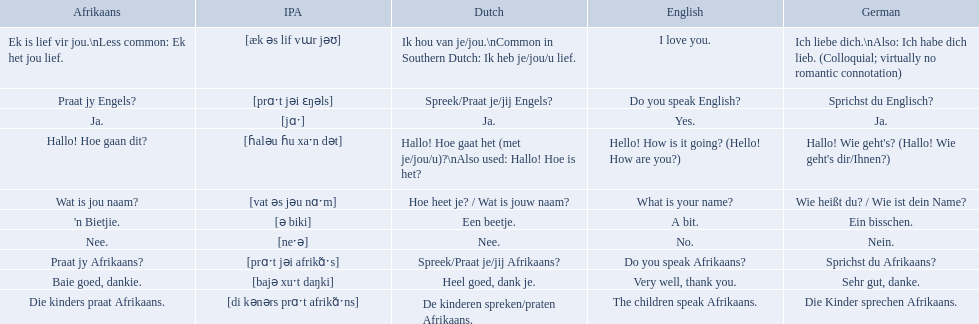What are the listed afrikaans phrases? Hallo! Hoe gaan dit?, Baie goed, dankie., Praat jy Afrikaans?, Praat jy Engels?, Ja., Nee., 'n Bietjie., Wat is jou naam?, Die kinders praat Afrikaans., Ek is lief vir jou.\nLess common: Ek het jou lief. Which is die kinders praat afrikaans? Die kinders praat Afrikaans. What is its german translation? Die Kinder sprechen Afrikaans. Which phrases are said in africaans? Hallo! Hoe gaan dit?, Baie goed, dankie., Praat jy Afrikaans?, Praat jy Engels?, Ja., Nee., 'n Bietjie., Wat is jou naam?, Die kinders praat Afrikaans., Ek is lief vir jou.\nLess common: Ek het jou lief. Which of these mean how do you speak afrikaans? Praat jy Afrikaans?. 